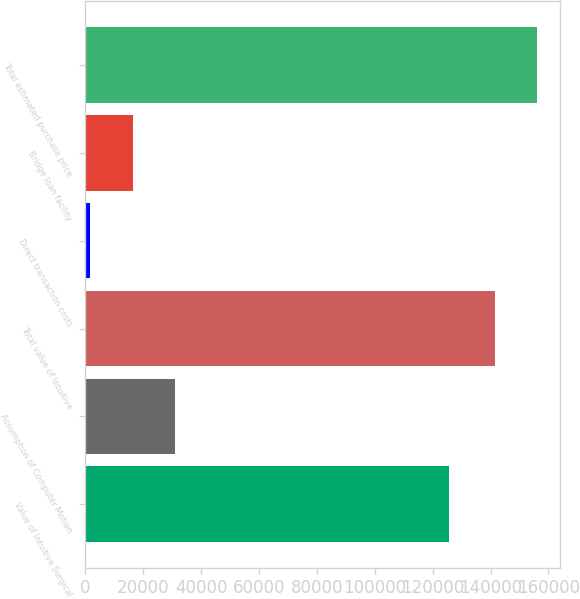Convert chart to OTSL. <chart><loc_0><loc_0><loc_500><loc_500><bar_chart><fcel>Value of Intuitive Surgical<fcel>Assumption of Computer Motion<fcel>Total value of Intuitive<fcel>Direct transaction costs<fcel>Bridge loan facility<fcel>Total estimated purchase price<nl><fcel>125734<fcel>31121.8<fcel>141437<fcel>1774<fcel>16447.9<fcel>156111<nl></chart> 